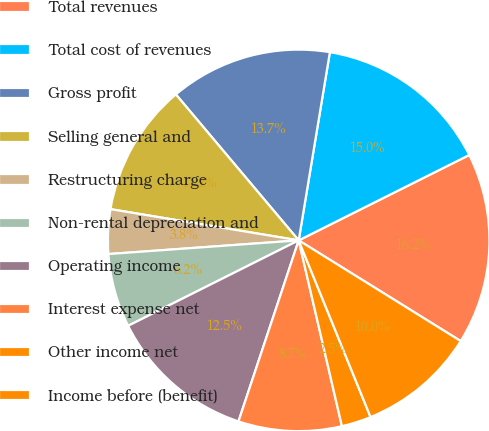Convert chart. <chart><loc_0><loc_0><loc_500><loc_500><pie_chart><fcel>Total revenues<fcel>Total cost of revenues<fcel>Gross profit<fcel>Selling general and<fcel>Restructuring charge<fcel>Non-rental depreciation and<fcel>Operating income<fcel>Interest expense net<fcel>Other income net<fcel>Income before (benefit)<nl><fcel>16.24%<fcel>15.0%<fcel>13.75%<fcel>11.25%<fcel>3.76%<fcel>6.25%<fcel>12.5%<fcel>8.75%<fcel>2.51%<fcel>10.0%<nl></chart> 